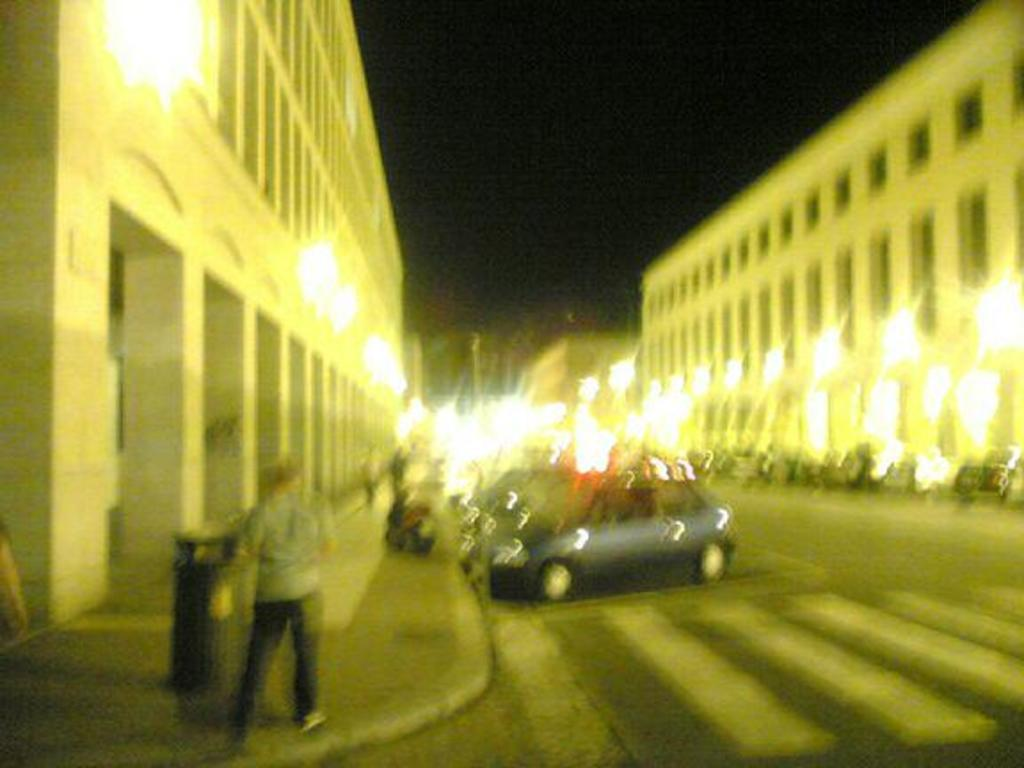Who or what can be seen in the image? There are people in the image. What else is present in the image besides people? There are vehicles on the road in the image. What can be seen in the distance in the image? There are buildings and lights visible in the background of the image. What part of the natural environment is visible in the image? The sky is visible in the background of the image. How many robins are perched on the buildings in the image? There are no robins present in the image. 